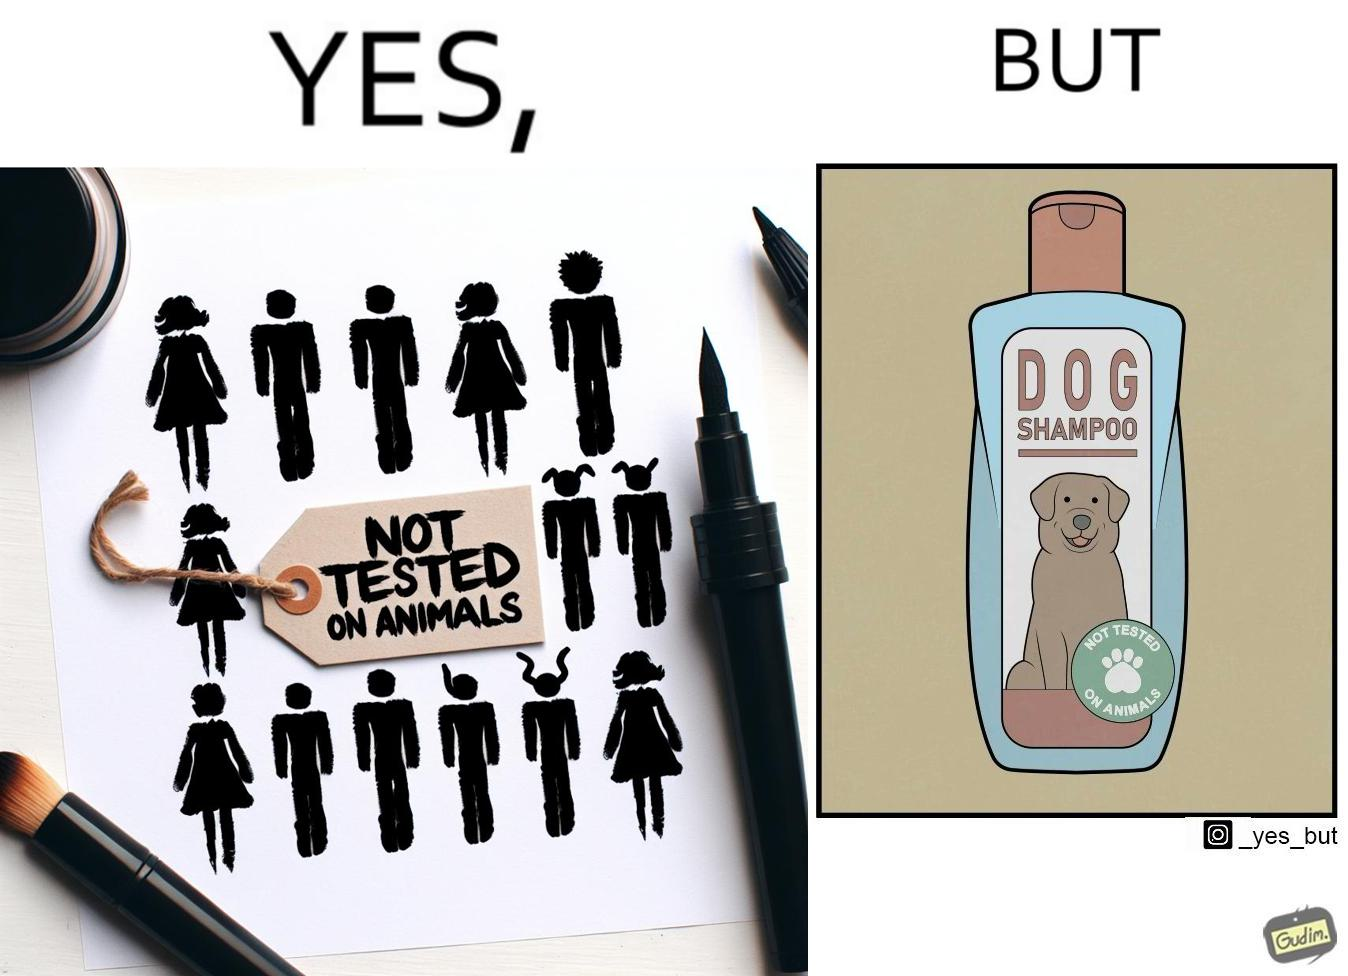Why is this image considered satirical? The images are ironic since a dog shampoo bottle has a sticker indicating that it has not been tested on animals and hence might not be safe for animal use. It is amusing that a product designed to be used by animals is not tested on animals for their safety 